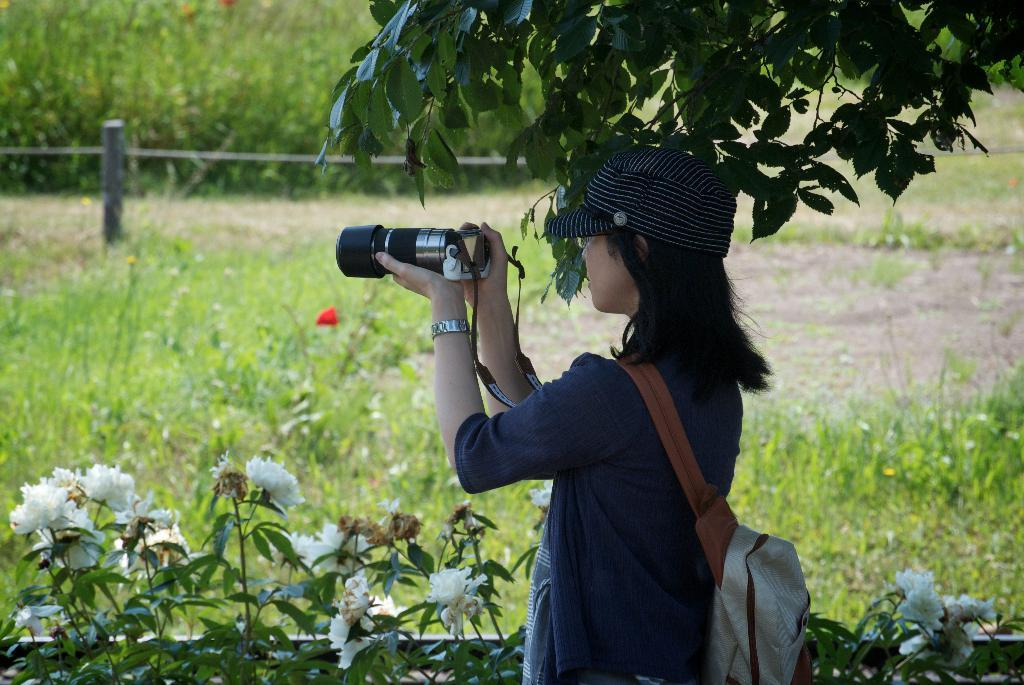Who is the main subject in the image? There is a woman in the image. What is the woman doing in the image? The woman is standing in the image. What is the woman holding in the image? The woman is holding a camera in the image. What can be seen in the background of the image? There are plants and a tree in the background of the image. What type of government is depicted in the image? There is no depiction of a government in the image; it features a woman standing with a camera and a background of plants and a tree. What body part is the woman using to hold the camera in the image? The woman is holding the camera with her hands in the image, not a specific body part. 